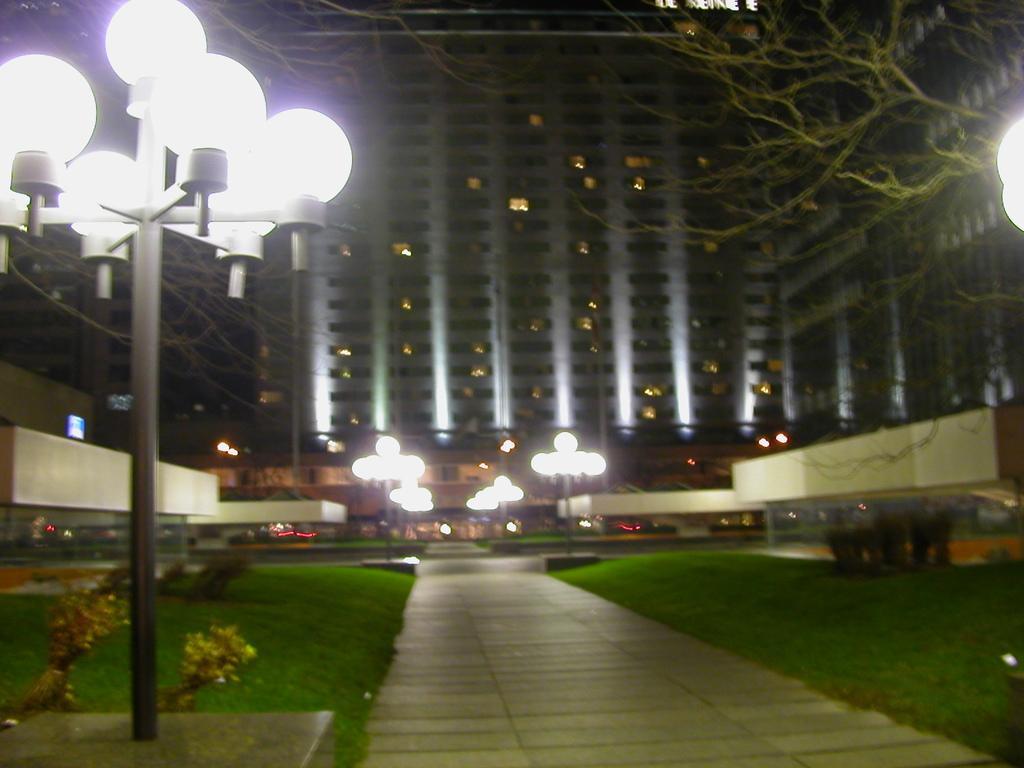Please provide a concise description of this image. In the left side there are white color lights and in the middle there is a very big building. In the right side there is a green color tree. 